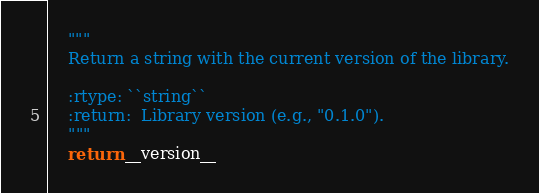<code> <loc_0><loc_0><loc_500><loc_500><_Python_>    """
    Return a string with the current version of the library.

    :rtype: ``string``
    :return:  Library version (e.g., "0.1.0").
    """
    return __version__
</code> 